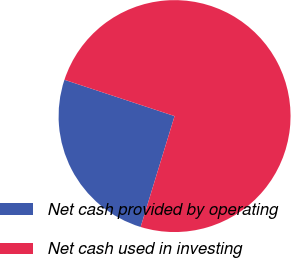Convert chart to OTSL. <chart><loc_0><loc_0><loc_500><loc_500><pie_chart><fcel>Net cash provided by operating<fcel>Net cash used in investing<nl><fcel>25.34%<fcel>74.66%<nl></chart> 